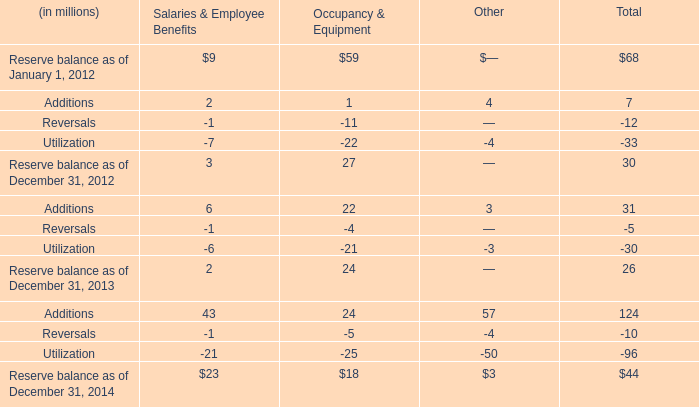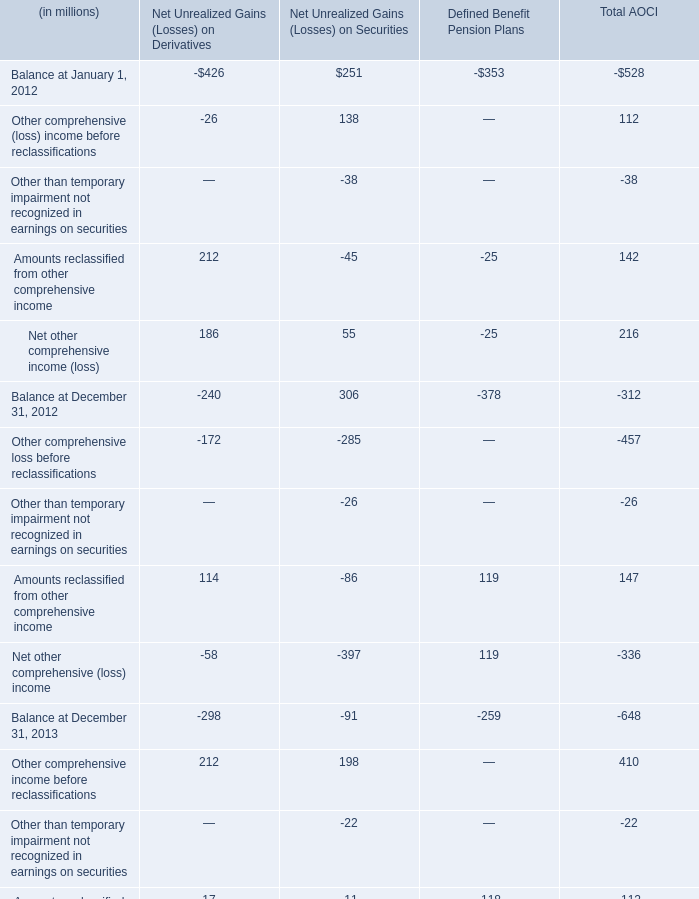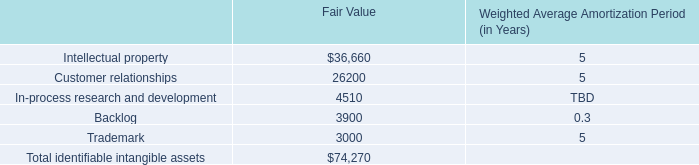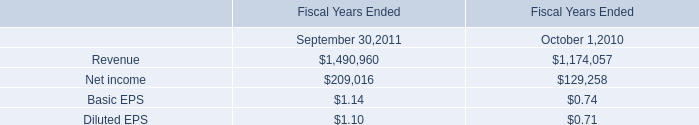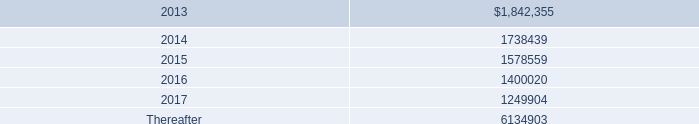What is the average growth rate of Balance at December 31 in Net Unrealized Gains (Losses) on Derivatives between 2013 and 2014? 
Computations: ((((-298 - -240) / -240) + ((-69 - -298) / -298)) / 2)
Answer: -0.26339. 